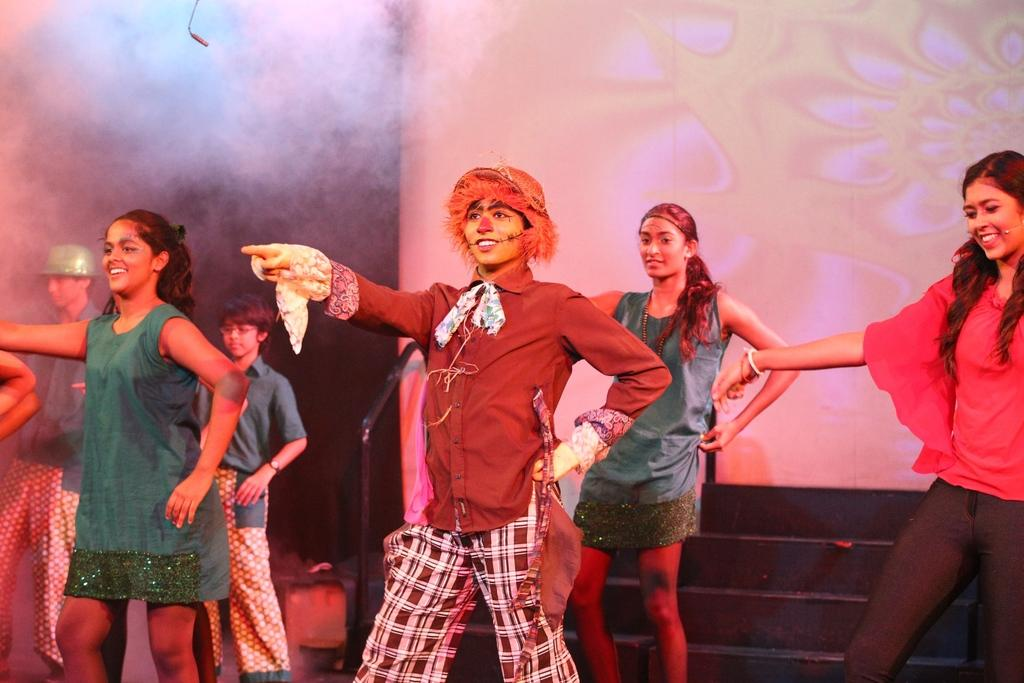How many people are in the image? There are people in the image, but the exact number is not specified. What are the people in the image doing? The people are standing in the image. What expression do the people have? The people are smiling in the image. What is visible in the background of the image? There is a wall in the background of the image. What type of fork can be seen in the image? There is no fork present in the image. Is there a chicken visible in the image? There is no chicken present in the image. What season is depicted in the image? The provided facts do not mention any season or time of year. 